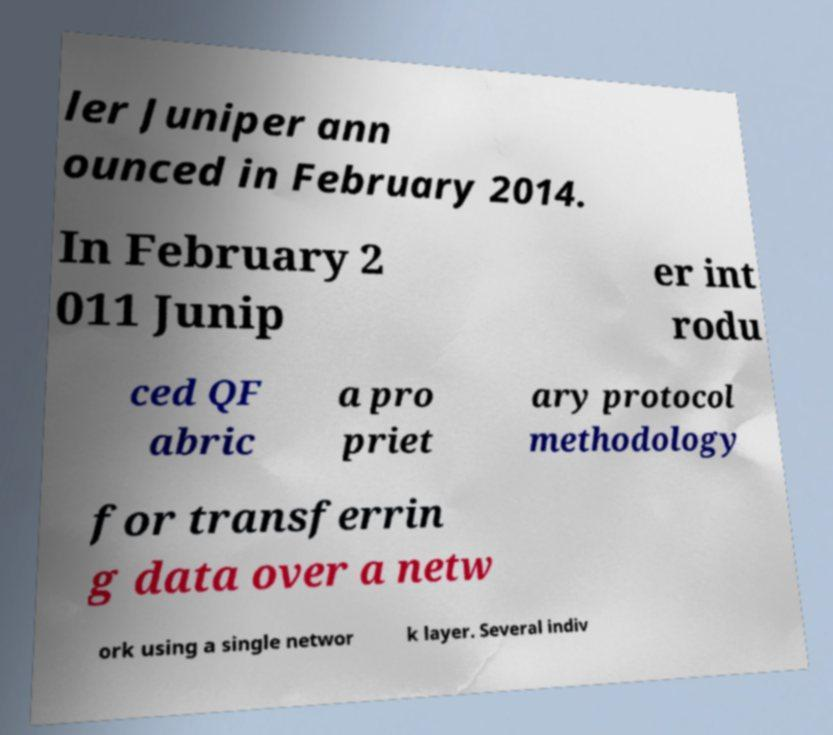Could you extract and type out the text from this image? ler Juniper ann ounced in February 2014. In February 2 011 Junip er int rodu ced QF abric a pro priet ary protocol methodology for transferrin g data over a netw ork using a single networ k layer. Several indiv 